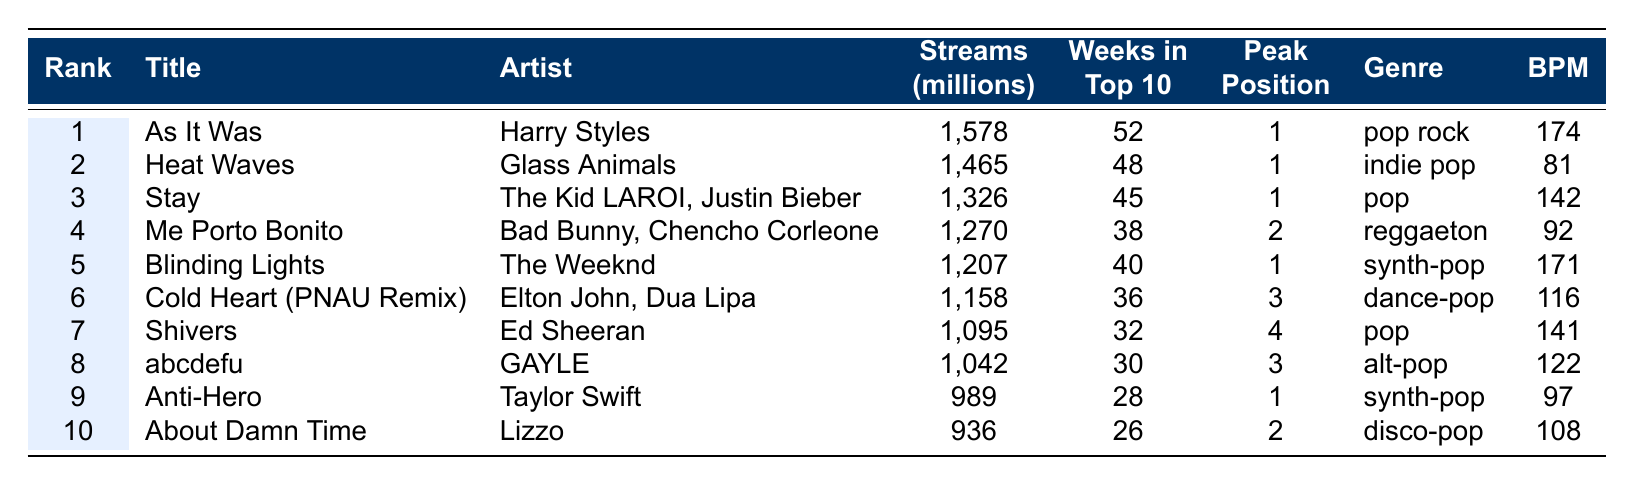What is the total number of streams for the top song? The top song "As It Was" has 1,578 million streams.
Answer: 1,578 million Which song had the highest peak position? The song "As It Was" ranked first, making it the highest peak position.
Answer: As It Was How many weeks in the top 10 did "Stay" spend? "Stay" was in the top 10 for 45 weeks, as shown in the table.
Answer: 45 weeks What genre is "Blinding Lights"? The genre of "Blinding Lights" is listed as synth-pop in the table.
Answer: Synth-pop What is the average number of streams for the top 10 songs? The total streams for the top 10 songs is 1,578 + 1,465 + 1,326 + 1,270 + 1,207 + 1,158 + 1,095 + 1,042 + 989 + 936 = 12,243 million. Thus, the average is 12,243/10 = 1,224.3 million.
Answer: 1,224.3 million Which song spent the fewest weeks in the top 10? "About Damn Time" spent the fewest weeks in the top 10, with only 26 weeks.
Answer: About Damn Time Did any song have a peak position lower than 3? Yes, "Me Porto Bonito" and "Shivers" had peak positions of 2 and 4, respectively, meaning at least one song had a peak position lower than 3.
Answer: Yes How many songs had streams over 1 billion? The songs that had over 1 billion streams are "As It Was," "Heat Waves," "Stay," "Me Porto Bonito," "Blinding Lights," "Cold Heart," "Shivers," "abcdefu," "Anti-Hero," and "About Damn Time," totaling ten songs.
Answer: 10 songs What is the total number of weeks all songs combined spent in the top 10? The total is 52 + 48 + 45 + 38 + 40 + 36 + 32 + 30 + 28 + 26 = 405 weeks combined for all songs in the top 10.
Answer: 405 weeks Which artist has the most streamed song? Harry Styles has the most streamed song with "As It Was," having 1,578 million streams.
Answer: Harry Styles 